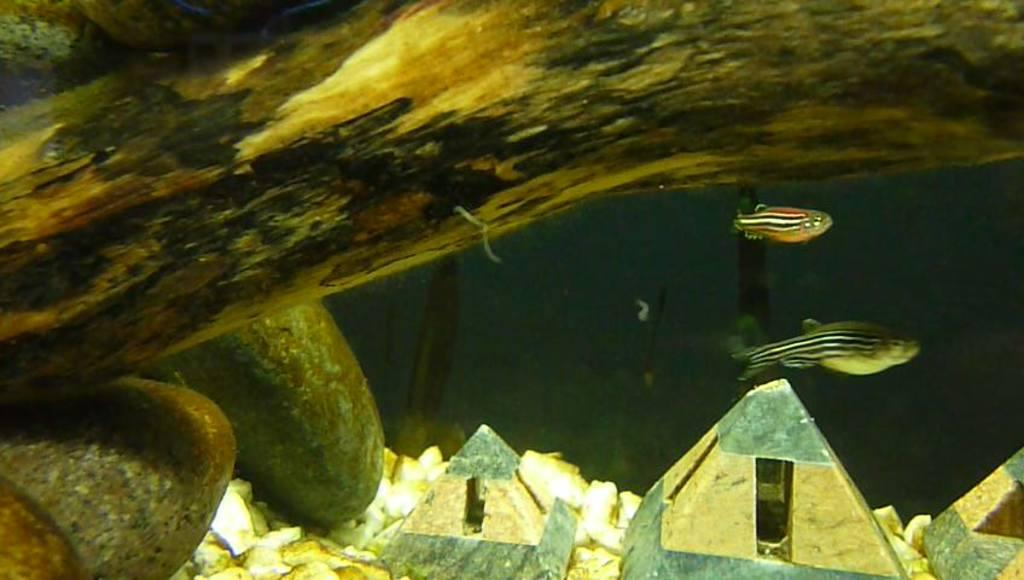What is the setting of the image? The image appears to be taken through an aquarium. What can be seen swimming in the water? There are two fishes swimming in the water. Are there any other objects visible in the image? Yes, there are two objects around the fishes. Can you see any plants being folded in the image? No, there are no plants or folding activity visible in the image. Is there a garden visible in the image? No, the image is taken through an aquarium, and there is no garden present. 